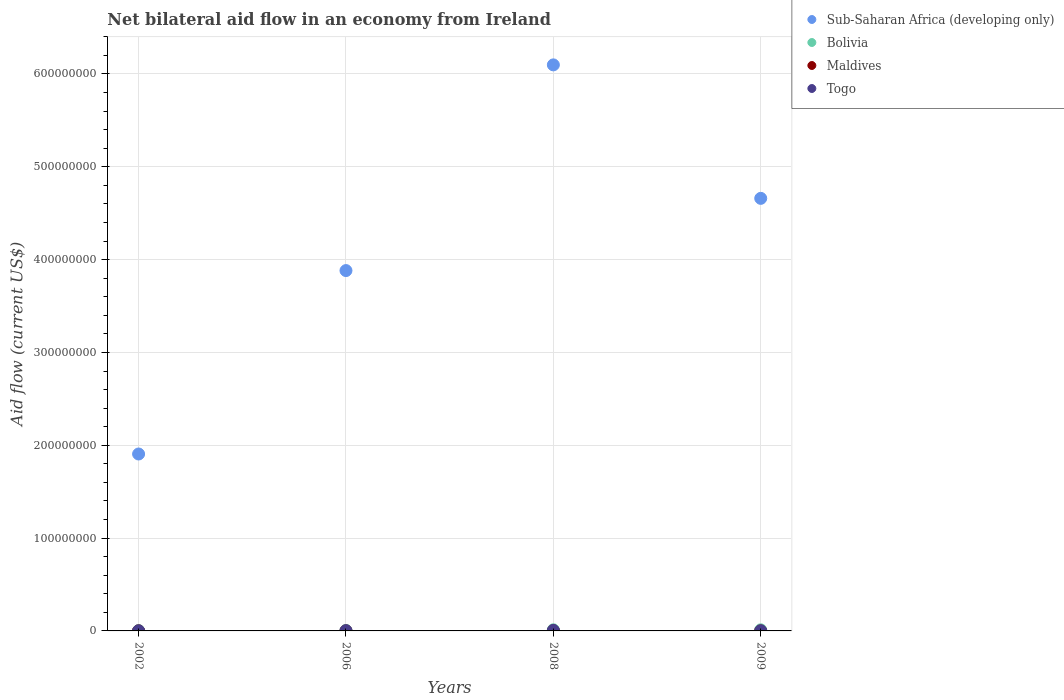How many different coloured dotlines are there?
Your response must be concise. 4. Is the number of dotlines equal to the number of legend labels?
Provide a succinct answer. Yes. What is the net bilateral aid flow in Sub-Saharan Africa (developing only) in 2008?
Offer a terse response. 6.10e+08. Across all years, what is the maximum net bilateral aid flow in Togo?
Give a very brief answer. 5.30e+05. Across all years, what is the minimum net bilateral aid flow in Sub-Saharan Africa (developing only)?
Your answer should be very brief. 1.91e+08. In which year was the net bilateral aid flow in Bolivia minimum?
Make the answer very short. 2002. What is the total net bilateral aid flow in Sub-Saharan Africa (developing only) in the graph?
Offer a terse response. 1.65e+09. What is the difference between the net bilateral aid flow in Togo in 2002 and that in 2008?
Provide a short and direct response. -4.70e+05. What is the average net bilateral aid flow in Maldives per year?
Offer a terse response. 6.25e+04. In the year 2006, what is the difference between the net bilateral aid flow in Togo and net bilateral aid flow in Bolivia?
Your answer should be compact. -3.20e+05. What is the ratio of the net bilateral aid flow in Sub-Saharan Africa (developing only) in 2002 to that in 2009?
Give a very brief answer. 0.41. Is the net bilateral aid flow in Togo in 2006 less than that in 2008?
Offer a terse response. Yes. What is the difference between the highest and the second highest net bilateral aid flow in Bolivia?
Ensure brevity in your answer.  4.00e+04. In how many years, is the net bilateral aid flow in Maldives greater than the average net bilateral aid flow in Maldives taken over all years?
Your response must be concise. 1. Is it the case that in every year, the sum of the net bilateral aid flow in Maldives and net bilateral aid flow in Sub-Saharan Africa (developing only)  is greater than the sum of net bilateral aid flow in Bolivia and net bilateral aid flow in Togo?
Provide a short and direct response. Yes. Is the net bilateral aid flow in Sub-Saharan Africa (developing only) strictly greater than the net bilateral aid flow in Maldives over the years?
Your answer should be compact. Yes. Is the net bilateral aid flow in Sub-Saharan Africa (developing only) strictly less than the net bilateral aid flow in Maldives over the years?
Provide a succinct answer. No. How many dotlines are there?
Offer a terse response. 4. What is the difference between two consecutive major ticks on the Y-axis?
Offer a very short reply. 1.00e+08. Does the graph contain any zero values?
Provide a succinct answer. No. Does the graph contain grids?
Your answer should be compact. Yes. How many legend labels are there?
Offer a very short reply. 4. How are the legend labels stacked?
Keep it short and to the point. Vertical. What is the title of the graph?
Give a very brief answer. Net bilateral aid flow in an economy from Ireland. What is the label or title of the X-axis?
Offer a terse response. Years. What is the label or title of the Y-axis?
Offer a terse response. Aid flow (current US$). What is the Aid flow (current US$) of Sub-Saharan Africa (developing only) in 2002?
Offer a very short reply. 1.91e+08. What is the Aid flow (current US$) of Maldives in 2002?
Your response must be concise. 3.00e+04. What is the Aid flow (current US$) of Togo in 2002?
Give a very brief answer. 6.00e+04. What is the Aid flow (current US$) of Sub-Saharan Africa (developing only) in 2006?
Make the answer very short. 3.88e+08. What is the Aid flow (current US$) of Bolivia in 2006?
Provide a short and direct response. 5.40e+05. What is the Aid flow (current US$) in Maldives in 2006?
Your answer should be compact. 10000. What is the Aid flow (current US$) of Togo in 2006?
Provide a short and direct response. 2.20e+05. What is the Aid flow (current US$) in Sub-Saharan Africa (developing only) in 2008?
Your answer should be compact. 6.10e+08. What is the Aid flow (current US$) of Bolivia in 2008?
Your response must be concise. 1.21e+06. What is the Aid flow (current US$) of Maldives in 2008?
Your answer should be very brief. 2.00e+05. What is the Aid flow (current US$) of Togo in 2008?
Give a very brief answer. 5.30e+05. What is the Aid flow (current US$) of Sub-Saharan Africa (developing only) in 2009?
Provide a short and direct response. 4.66e+08. What is the Aid flow (current US$) of Bolivia in 2009?
Keep it short and to the point. 1.17e+06. Across all years, what is the maximum Aid flow (current US$) in Sub-Saharan Africa (developing only)?
Your answer should be compact. 6.10e+08. Across all years, what is the maximum Aid flow (current US$) of Bolivia?
Make the answer very short. 1.21e+06. Across all years, what is the maximum Aid flow (current US$) in Togo?
Keep it short and to the point. 5.30e+05. Across all years, what is the minimum Aid flow (current US$) in Sub-Saharan Africa (developing only)?
Your answer should be compact. 1.91e+08. Across all years, what is the minimum Aid flow (current US$) of Bolivia?
Your answer should be very brief. 3.90e+05. Across all years, what is the minimum Aid flow (current US$) of Maldives?
Keep it short and to the point. 10000. What is the total Aid flow (current US$) in Sub-Saharan Africa (developing only) in the graph?
Give a very brief answer. 1.65e+09. What is the total Aid flow (current US$) in Bolivia in the graph?
Offer a very short reply. 3.31e+06. What is the total Aid flow (current US$) in Maldives in the graph?
Your answer should be very brief. 2.50e+05. What is the total Aid flow (current US$) of Togo in the graph?
Make the answer very short. 9.50e+05. What is the difference between the Aid flow (current US$) in Sub-Saharan Africa (developing only) in 2002 and that in 2006?
Your response must be concise. -1.98e+08. What is the difference between the Aid flow (current US$) in Bolivia in 2002 and that in 2006?
Provide a succinct answer. -1.50e+05. What is the difference between the Aid flow (current US$) of Maldives in 2002 and that in 2006?
Offer a terse response. 2.00e+04. What is the difference between the Aid flow (current US$) of Sub-Saharan Africa (developing only) in 2002 and that in 2008?
Make the answer very short. -4.19e+08. What is the difference between the Aid flow (current US$) of Bolivia in 2002 and that in 2008?
Keep it short and to the point. -8.20e+05. What is the difference between the Aid flow (current US$) of Togo in 2002 and that in 2008?
Make the answer very short. -4.70e+05. What is the difference between the Aid flow (current US$) of Sub-Saharan Africa (developing only) in 2002 and that in 2009?
Offer a very short reply. -2.75e+08. What is the difference between the Aid flow (current US$) in Bolivia in 2002 and that in 2009?
Your answer should be compact. -7.80e+05. What is the difference between the Aid flow (current US$) in Maldives in 2002 and that in 2009?
Offer a terse response. 2.00e+04. What is the difference between the Aid flow (current US$) of Togo in 2002 and that in 2009?
Offer a very short reply. -8.00e+04. What is the difference between the Aid flow (current US$) in Sub-Saharan Africa (developing only) in 2006 and that in 2008?
Your answer should be very brief. -2.22e+08. What is the difference between the Aid flow (current US$) in Bolivia in 2006 and that in 2008?
Make the answer very short. -6.70e+05. What is the difference between the Aid flow (current US$) of Maldives in 2006 and that in 2008?
Provide a succinct answer. -1.90e+05. What is the difference between the Aid flow (current US$) of Togo in 2006 and that in 2008?
Offer a very short reply. -3.10e+05. What is the difference between the Aid flow (current US$) in Sub-Saharan Africa (developing only) in 2006 and that in 2009?
Give a very brief answer. -7.78e+07. What is the difference between the Aid flow (current US$) in Bolivia in 2006 and that in 2009?
Your response must be concise. -6.30e+05. What is the difference between the Aid flow (current US$) of Togo in 2006 and that in 2009?
Make the answer very short. 8.00e+04. What is the difference between the Aid flow (current US$) of Sub-Saharan Africa (developing only) in 2008 and that in 2009?
Offer a terse response. 1.44e+08. What is the difference between the Aid flow (current US$) of Bolivia in 2008 and that in 2009?
Give a very brief answer. 4.00e+04. What is the difference between the Aid flow (current US$) in Maldives in 2008 and that in 2009?
Your answer should be compact. 1.90e+05. What is the difference between the Aid flow (current US$) in Sub-Saharan Africa (developing only) in 2002 and the Aid flow (current US$) in Bolivia in 2006?
Make the answer very short. 1.90e+08. What is the difference between the Aid flow (current US$) of Sub-Saharan Africa (developing only) in 2002 and the Aid flow (current US$) of Maldives in 2006?
Ensure brevity in your answer.  1.91e+08. What is the difference between the Aid flow (current US$) of Sub-Saharan Africa (developing only) in 2002 and the Aid flow (current US$) of Togo in 2006?
Offer a terse response. 1.90e+08. What is the difference between the Aid flow (current US$) in Bolivia in 2002 and the Aid flow (current US$) in Maldives in 2006?
Your response must be concise. 3.80e+05. What is the difference between the Aid flow (current US$) in Sub-Saharan Africa (developing only) in 2002 and the Aid flow (current US$) in Bolivia in 2008?
Offer a very short reply. 1.89e+08. What is the difference between the Aid flow (current US$) in Sub-Saharan Africa (developing only) in 2002 and the Aid flow (current US$) in Maldives in 2008?
Offer a very short reply. 1.90e+08. What is the difference between the Aid flow (current US$) in Sub-Saharan Africa (developing only) in 2002 and the Aid flow (current US$) in Togo in 2008?
Provide a succinct answer. 1.90e+08. What is the difference between the Aid flow (current US$) in Bolivia in 2002 and the Aid flow (current US$) in Maldives in 2008?
Offer a very short reply. 1.90e+05. What is the difference between the Aid flow (current US$) in Maldives in 2002 and the Aid flow (current US$) in Togo in 2008?
Your response must be concise. -5.00e+05. What is the difference between the Aid flow (current US$) of Sub-Saharan Africa (developing only) in 2002 and the Aid flow (current US$) of Bolivia in 2009?
Keep it short and to the point. 1.89e+08. What is the difference between the Aid flow (current US$) in Sub-Saharan Africa (developing only) in 2002 and the Aid flow (current US$) in Maldives in 2009?
Offer a terse response. 1.91e+08. What is the difference between the Aid flow (current US$) in Sub-Saharan Africa (developing only) in 2002 and the Aid flow (current US$) in Togo in 2009?
Give a very brief answer. 1.90e+08. What is the difference between the Aid flow (current US$) in Sub-Saharan Africa (developing only) in 2006 and the Aid flow (current US$) in Bolivia in 2008?
Offer a very short reply. 3.87e+08. What is the difference between the Aid flow (current US$) in Sub-Saharan Africa (developing only) in 2006 and the Aid flow (current US$) in Maldives in 2008?
Give a very brief answer. 3.88e+08. What is the difference between the Aid flow (current US$) in Sub-Saharan Africa (developing only) in 2006 and the Aid flow (current US$) in Togo in 2008?
Provide a short and direct response. 3.88e+08. What is the difference between the Aid flow (current US$) of Bolivia in 2006 and the Aid flow (current US$) of Maldives in 2008?
Your answer should be compact. 3.40e+05. What is the difference between the Aid flow (current US$) of Bolivia in 2006 and the Aid flow (current US$) of Togo in 2008?
Provide a short and direct response. 10000. What is the difference between the Aid flow (current US$) in Maldives in 2006 and the Aid flow (current US$) in Togo in 2008?
Provide a short and direct response. -5.20e+05. What is the difference between the Aid flow (current US$) in Sub-Saharan Africa (developing only) in 2006 and the Aid flow (current US$) in Bolivia in 2009?
Provide a short and direct response. 3.87e+08. What is the difference between the Aid flow (current US$) in Sub-Saharan Africa (developing only) in 2006 and the Aid flow (current US$) in Maldives in 2009?
Make the answer very short. 3.88e+08. What is the difference between the Aid flow (current US$) in Sub-Saharan Africa (developing only) in 2006 and the Aid flow (current US$) in Togo in 2009?
Your answer should be very brief. 3.88e+08. What is the difference between the Aid flow (current US$) of Bolivia in 2006 and the Aid flow (current US$) of Maldives in 2009?
Make the answer very short. 5.30e+05. What is the difference between the Aid flow (current US$) of Sub-Saharan Africa (developing only) in 2008 and the Aid flow (current US$) of Bolivia in 2009?
Give a very brief answer. 6.09e+08. What is the difference between the Aid flow (current US$) of Sub-Saharan Africa (developing only) in 2008 and the Aid flow (current US$) of Maldives in 2009?
Ensure brevity in your answer.  6.10e+08. What is the difference between the Aid flow (current US$) in Sub-Saharan Africa (developing only) in 2008 and the Aid flow (current US$) in Togo in 2009?
Provide a succinct answer. 6.10e+08. What is the difference between the Aid flow (current US$) of Bolivia in 2008 and the Aid flow (current US$) of Maldives in 2009?
Offer a terse response. 1.20e+06. What is the difference between the Aid flow (current US$) in Bolivia in 2008 and the Aid flow (current US$) in Togo in 2009?
Keep it short and to the point. 1.07e+06. What is the difference between the Aid flow (current US$) of Maldives in 2008 and the Aid flow (current US$) of Togo in 2009?
Make the answer very short. 6.00e+04. What is the average Aid flow (current US$) in Sub-Saharan Africa (developing only) per year?
Make the answer very short. 4.14e+08. What is the average Aid flow (current US$) in Bolivia per year?
Keep it short and to the point. 8.28e+05. What is the average Aid flow (current US$) in Maldives per year?
Ensure brevity in your answer.  6.25e+04. What is the average Aid flow (current US$) of Togo per year?
Ensure brevity in your answer.  2.38e+05. In the year 2002, what is the difference between the Aid flow (current US$) of Sub-Saharan Africa (developing only) and Aid flow (current US$) of Bolivia?
Provide a succinct answer. 1.90e+08. In the year 2002, what is the difference between the Aid flow (current US$) in Sub-Saharan Africa (developing only) and Aid flow (current US$) in Maldives?
Provide a short and direct response. 1.91e+08. In the year 2002, what is the difference between the Aid flow (current US$) in Sub-Saharan Africa (developing only) and Aid flow (current US$) in Togo?
Offer a terse response. 1.91e+08. In the year 2002, what is the difference between the Aid flow (current US$) of Bolivia and Aid flow (current US$) of Maldives?
Ensure brevity in your answer.  3.60e+05. In the year 2002, what is the difference between the Aid flow (current US$) of Maldives and Aid flow (current US$) of Togo?
Keep it short and to the point. -3.00e+04. In the year 2006, what is the difference between the Aid flow (current US$) in Sub-Saharan Africa (developing only) and Aid flow (current US$) in Bolivia?
Ensure brevity in your answer.  3.88e+08. In the year 2006, what is the difference between the Aid flow (current US$) in Sub-Saharan Africa (developing only) and Aid flow (current US$) in Maldives?
Offer a terse response. 3.88e+08. In the year 2006, what is the difference between the Aid flow (current US$) in Sub-Saharan Africa (developing only) and Aid flow (current US$) in Togo?
Provide a succinct answer. 3.88e+08. In the year 2006, what is the difference between the Aid flow (current US$) in Bolivia and Aid flow (current US$) in Maldives?
Offer a very short reply. 5.30e+05. In the year 2006, what is the difference between the Aid flow (current US$) of Bolivia and Aid flow (current US$) of Togo?
Provide a short and direct response. 3.20e+05. In the year 2008, what is the difference between the Aid flow (current US$) of Sub-Saharan Africa (developing only) and Aid flow (current US$) of Bolivia?
Your answer should be compact. 6.09e+08. In the year 2008, what is the difference between the Aid flow (current US$) in Sub-Saharan Africa (developing only) and Aid flow (current US$) in Maldives?
Your response must be concise. 6.10e+08. In the year 2008, what is the difference between the Aid flow (current US$) of Sub-Saharan Africa (developing only) and Aid flow (current US$) of Togo?
Offer a terse response. 6.09e+08. In the year 2008, what is the difference between the Aid flow (current US$) in Bolivia and Aid flow (current US$) in Maldives?
Ensure brevity in your answer.  1.01e+06. In the year 2008, what is the difference between the Aid flow (current US$) in Bolivia and Aid flow (current US$) in Togo?
Your response must be concise. 6.80e+05. In the year 2008, what is the difference between the Aid flow (current US$) of Maldives and Aid flow (current US$) of Togo?
Ensure brevity in your answer.  -3.30e+05. In the year 2009, what is the difference between the Aid flow (current US$) in Sub-Saharan Africa (developing only) and Aid flow (current US$) in Bolivia?
Your response must be concise. 4.65e+08. In the year 2009, what is the difference between the Aid flow (current US$) of Sub-Saharan Africa (developing only) and Aid flow (current US$) of Maldives?
Provide a short and direct response. 4.66e+08. In the year 2009, what is the difference between the Aid flow (current US$) of Sub-Saharan Africa (developing only) and Aid flow (current US$) of Togo?
Provide a succinct answer. 4.66e+08. In the year 2009, what is the difference between the Aid flow (current US$) in Bolivia and Aid flow (current US$) in Maldives?
Ensure brevity in your answer.  1.16e+06. In the year 2009, what is the difference between the Aid flow (current US$) in Bolivia and Aid flow (current US$) in Togo?
Ensure brevity in your answer.  1.03e+06. In the year 2009, what is the difference between the Aid flow (current US$) of Maldives and Aid flow (current US$) of Togo?
Offer a very short reply. -1.30e+05. What is the ratio of the Aid flow (current US$) of Sub-Saharan Africa (developing only) in 2002 to that in 2006?
Your answer should be compact. 0.49. What is the ratio of the Aid flow (current US$) of Bolivia in 2002 to that in 2006?
Provide a succinct answer. 0.72. What is the ratio of the Aid flow (current US$) of Maldives in 2002 to that in 2006?
Your answer should be compact. 3. What is the ratio of the Aid flow (current US$) of Togo in 2002 to that in 2006?
Your answer should be compact. 0.27. What is the ratio of the Aid flow (current US$) of Sub-Saharan Africa (developing only) in 2002 to that in 2008?
Provide a short and direct response. 0.31. What is the ratio of the Aid flow (current US$) in Bolivia in 2002 to that in 2008?
Make the answer very short. 0.32. What is the ratio of the Aid flow (current US$) in Maldives in 2002 to that in 2008?
Offer a terse response. 0.15. What is the ratio of the Aid flow (current US$) in Togo in 2002 to that in 2008?
Offer a very short reply. 0.11. What is the ratio of the Aid flow (current US$) of Sub-Saharan Africa (developing only) in 2002 to that in 2009?
Make the answer very short. 0.41. What is the ratio of the Aid flow (current US$) of Bolivia in 2002 to that in 2009?
Your response must be concise. 0.33. What is the ratio of the Aid flow (current US$) in Maldives in 2002 to that in 2009?
Make the answer very short. 3. What is the ratio of the Aid flow (current US$) of Togo in 2002 to that in 2009?
Your answer should be compact. 0.43. What is the ratio of the Aid flow (current US$) in Sub-Saharan Africa (developing only) in 2006 to that in 2008?
Offer a terse response. 0.64. What is the ratio of the Aid flow (current US$) of Bolivia in 2006 to that in 2008?
Offer a very short reply. 0.45. What is the ratio of the Aid flow (current US$) of Maldives in 2006 to that in 2008?
Provide a succinct answer. 0.05. What is the ratio of the Aid flow (current US$) in Togo in 2006 to that in 2008?
Offer a terse response. 0.42. What is the ratio of the Aid flow (current US$) in Sub-Saharan Africa (developing only) in 2006 to that in 2009?
Offer a terse response. 0.83. What is the ratio of the Aid flow (current US$) of Bolivia in 2006 to that in 2009?
Keep it short and to the point. 0.46. What is the ratio of the Aid flow (current US$) in Togo in 2006 to that in 2009?
Your answer should be very brief. 1.57. What is the ratio of the Aid flow (current US$) of Sub-Saharan Africa (developing only) in 2008 to that in 2009?
Your answer should be compact. 1.31. What is the ratio of the Aid flow (current US$) in Bolivia in 2008 to that in 2009?
Offer a very short reply. 1.03. What is the ratio of the Aid flow (current US$) of Togo in 2008 to that in 2009?
Your answer should be very brief. 3.79. What is the difference between the highest and the second highest Aid flow (current US$) of Sub-Saharan Africa (developing only)?
Provide a succinct answer. 1.44e+08. What is the difference between the highest and the second highest Aid flow (current US$) of Maldives?
Offer a very short reply. 1.70e+05. What is the difference between the highest and the second highest Aid flow (current US$) of Togo?
Provide a succinct answer. 3.10e+05. What is the difference between the highest and the lowest Aid flow (current US$) of Sub-Saharan Africa (developing only)?
Your answer should be compact. 4.19e+08. What is the difference between the highest and the lowest Aid flow (current US$) in Bolivia?
Keep it short and to the point. 8.20e+05. What is the difference between the highest and the lowest Aid flow (current US$) of Maldives?
Provide a short and direct response. 1.90e+05. 